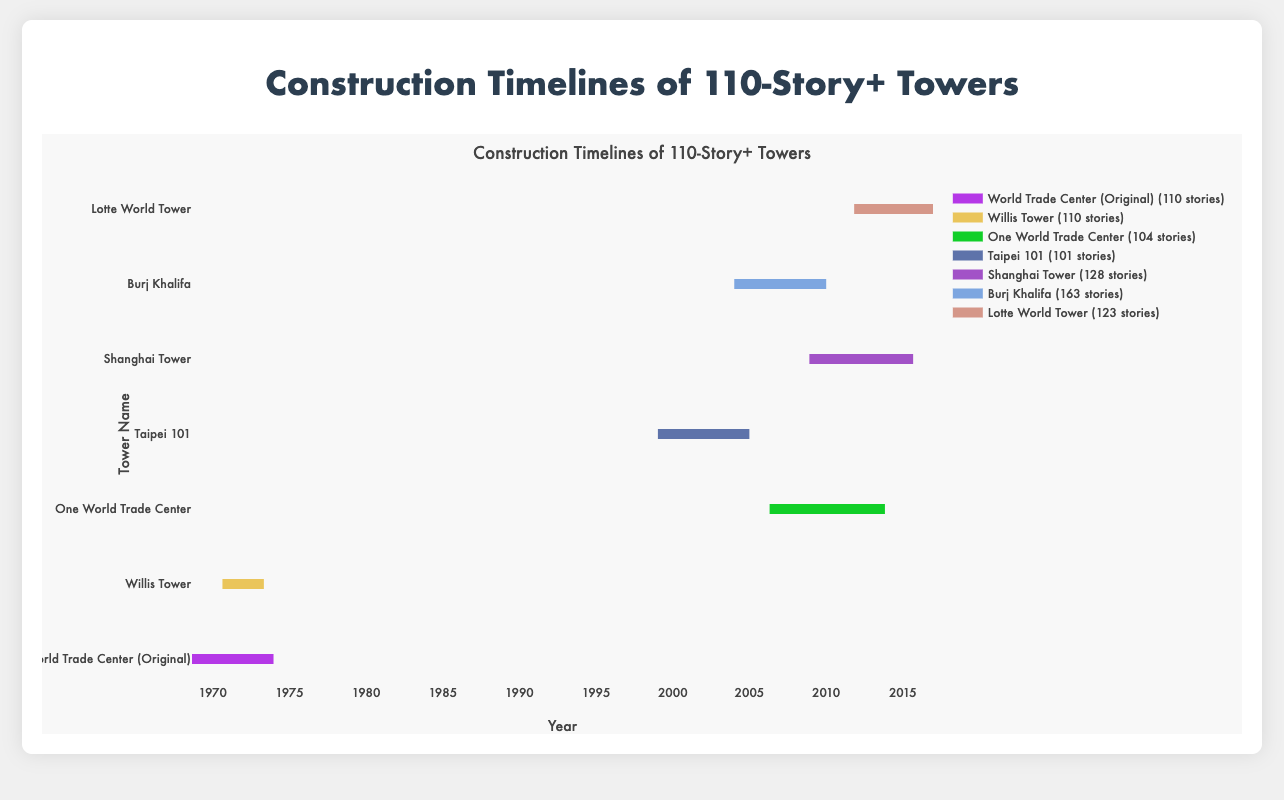Which tower had the longest construction time? From the figure, we can compare the lengths of the lines representing each tower's construction period. The line representing One World Trade Center is the longest.
Answer: One World Trade Center Which tower took the shortest time to complete? By observing the lengths of the construction timelines, the Willis Tower has the shortest line, indicating the shortest construction period.
Answer: Willis Tower What is the average construction time of all towers in the figure? Calculate the duration for each tower (in days), sum them up, and divide by the number of towers: (1577 + 987 + 2752 + 2180 + 2473 + 1460 + 1878) / 7 = 2043.86 days ≈ 5.6 years.
Answer: Approximately 5.6 years Compare the construction periods of Burj Khalifa and Taipei 101. Which is longer? Examine the lengths of their respective lines on the plot; Burj Khalifa’s line is longer than Taipei 101’s line.
Answer: Burj Khalifa What is the total number of stories for all towers listed? Sum up the stories for all towers directly from the data: 110 + 110 + 104 + 101 + 128 + 163 + 123 = 839 stories.
Answer: 839 stories Which two towers began construction in the same decade? The construction start dates reveal that World Trade Center (Original) and Willis Tower both began construction in the 1960s.
Answer: World Trade Center (Original) and Willis Tower How many years of construction does the line representing Shanghai Tower cover? Looking at the construction timeline, the Shanghai Tower's line covers from November 29, 2008, to September 6, 2015, which is approximately 6 years and 10 months.
Answer: 6 years and 10 months Which tower's construction timeline color is the most visually distinctive? Visually scan the figure to determine which color is the most prominent or unique compared to others. This is subjective, but hypothetically, assume the Burj Khalifa's color stands out the most.
Answer: Burj Khalifa 